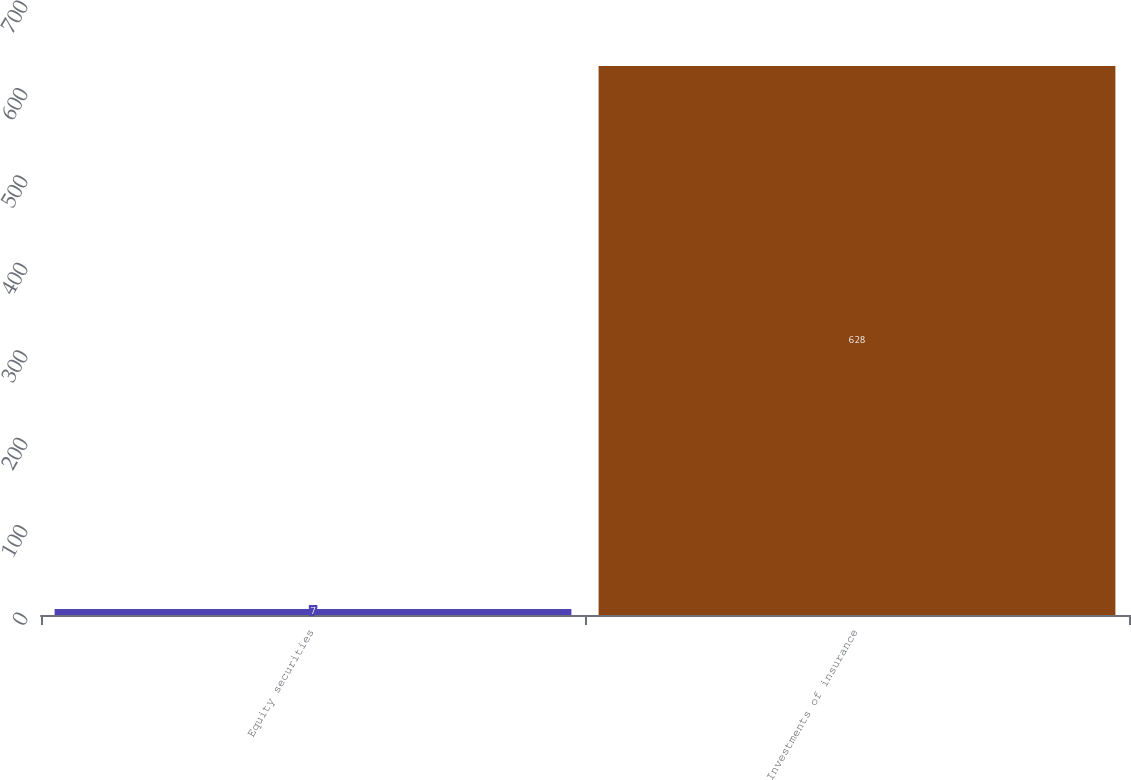Convert chart to OTSL. <chart><loc_0><loc_0><loc_500><loc_500><bar_chart><fcel>Equity securities<fcel>Investments of insurance<nl><fcel>7<fcel>628<nl></chart> 